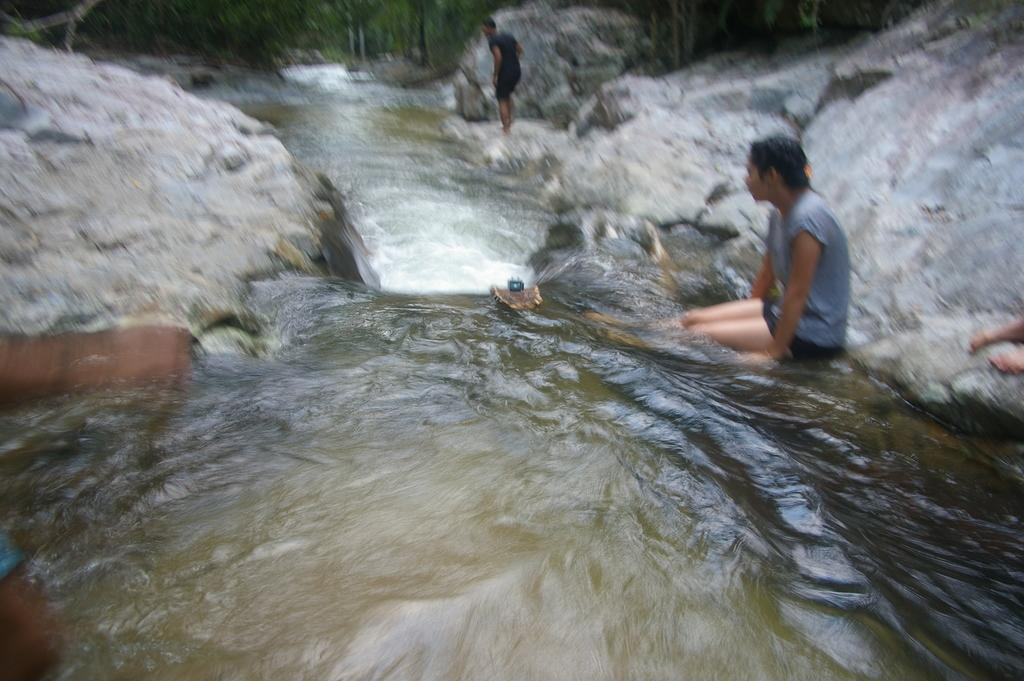What type of natural formations can be seen in the image? There are big rocks in the image. Are there any living beings present in the image? Yes, there are people in the image. What is the source of water in the image? There is a flow of water in the image. What type of vegetation is present in the image? There are many trees in the image. Can you see any magic spells being cast in the image? There is no mention of magic or spells in the image; it features big rocks, people, a flow of water, and many trees. Are there any bananas hanging from the trees in the image? There is no mention of bananas or any fruits in the image; it only mentions trees. 